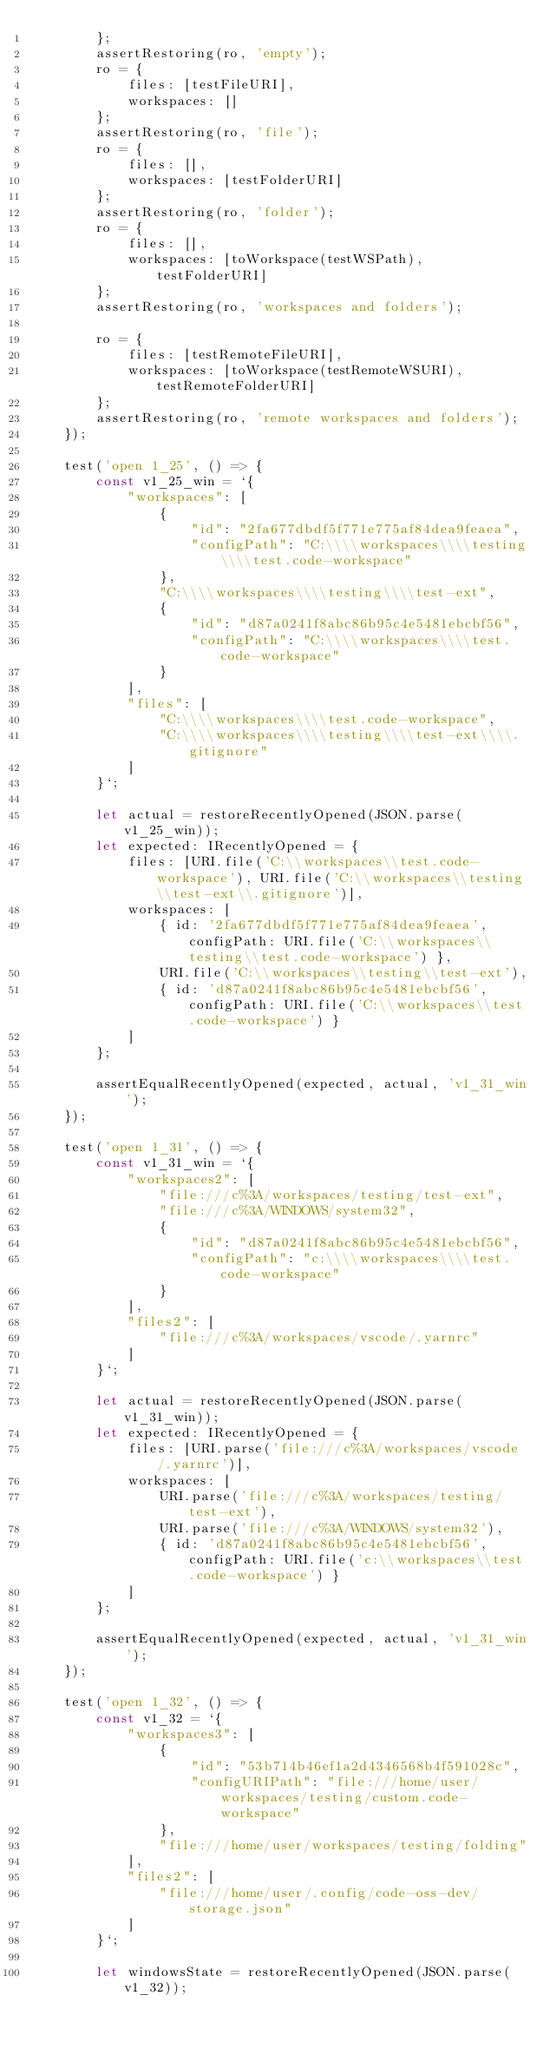Convert code to text. <code><loc_0><loc_0><loc_500><loc_500><_TypeScript_>		};
		assertRestoring(ro, 'empty');
		ro = {
			files: [testFileURI],
			workspaces: []
		};
		assertRestoring(ro, 'file');
		ro = {
			files: [],
			workspaces: [testFolderURI]
		};
		assertRestoring(ro, 'folder');
		ro = {
			files: [],
			workspaces: [toWorkspace(testWSPath), testFolderURI]
		};
		assertRestoring(ro, 'workspaces and folders');

		ro = {
			files: [testRemoteFileURI],
			workspaces: [toWorkspace(testRemoteWSURI), testRemoteFolderURI]
		};
		assertRestoring(ro, 'remote workspaces and folders');
	});

	test('open 1_25', () => {
		const v1_25_win = `{
			"workspaces": [
				{
					"id": "2fa677dbdf5f771e775af84dea9feaea",
					"configPath": "C:\\\\workspaces\\\\testing\\\\test.code-workspace"
				},
				"C:\\\\workspaces\\\\testing\\\\test-ext",
				{
					"id": "d87a0241f8abc86b95c4e5481ebcbf56",
					"configPath": "C:\\\\workspaces\\\\test.code-workspace"
				}
			],
			"files": [
				"C:\\\\workspaces\\\\test.code-workspace",
				"C:\\\\workspaces\\\\testing\\\\test-ext\\\\.gitignore"
			]
		}`;

		let actual = restoreRecentlyOpened(JSON.parse(v1_25_win));
		let expected: IRecentlyOpened = {
			files: [URI.file('C:\\workspaces\\test.code-workspace'), URI.file('C:\\workspaces\\testing\\test-ext\\.gitignore')],
			workspaces: [
				{ id: '2fa677dbdf5f771e775af84dea9feaea', configPath: URI.file('C:\\workspaces\\testing\\test.code-workspace') },
				URI.file('C:\\workspaces\\testing\\test-ext'),
				{ id: 'd87a0241f8abc86b95c4e5481ebcbf56', configPath: URI.file('C:\\workspaces\\test.code-workspace') }
			]
		};

		assertEqualRecentlyOpened(expected, actual, 'v1_31_win');
	});

	test('open 1_31', () => {
		const v1_31_win = `{
			"workspaces2": [
				"file:///c%3A/workspaces/testing/test-ext",
				"file:///c%3A/WINDOWS/system32",
				{
					"id": "d87a0241f8abc86b95c4e5481ebcbf56",
					"configPath": "c:\\\\workspaces\\\\test.code-workspace"
				}
			],
			"files2": [
				"file:///c%3A/workspaces/vscode/.yarnrc"
			]
		}`;

		let actual = restoreRecentlyOpened(JSON.parse(v1_31_win));
		let expected: IRecentlyOpened = {
			files: [URI.parse('file:///c%3A/workspaces/vscode/.yarnrc')],
			workspaces: [
				URI.parse('file:///c%3A/workspaces/testing/test-ext'),
				URI.parse('file:///c%3A/WINDOWS/system32'),
				{ id: 'd87a0241f8abc86b95c4e5481ebcbf56', configPath: URI.file('c:\\workspaces\\test.code-workspace') }
			]
		};

		assertEqualRecentlyOpened(expected, actual, 'v1_31_win');
	});

	test('open 1_32', () => {
		const v1_32 = `{
			"workspaces3": [
				{
					"id": "53b714b46ef1a2d4346568b4f591028c",
					"configURIPath": "file:///home/user/workspaces/testing/custom.code-workspace"
				},
				"file:///home/user/workspaces/testing/folding"
			],
			"files2": [
				"file:///home/user/.config/code-oss-dev/storage.json"
			]
		}`;

		let windowsState = restoreRecentlyOpened(JSON.parse(v1_32));</code> 